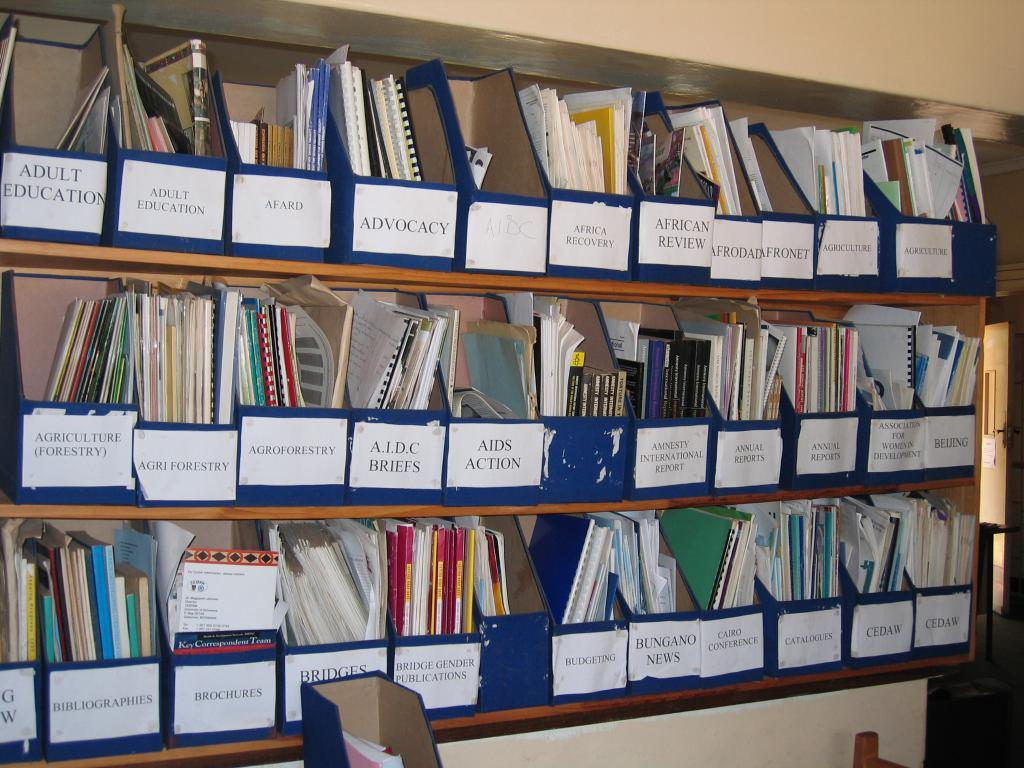<image>
Relay a brief, clear account of the picture shown. many books and one that says budgeting on it 